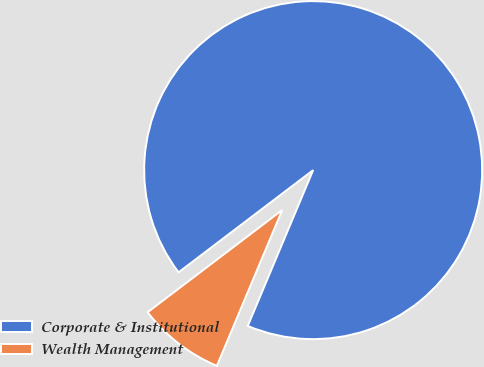<chart> <loc_0><loc_0><loc_500><loc_500><pie_chart><fcel>Corporate & Institutional<fcel>Wealth Management<nl><fcel>91.66%<fcel>8.34%<nl></chart> 